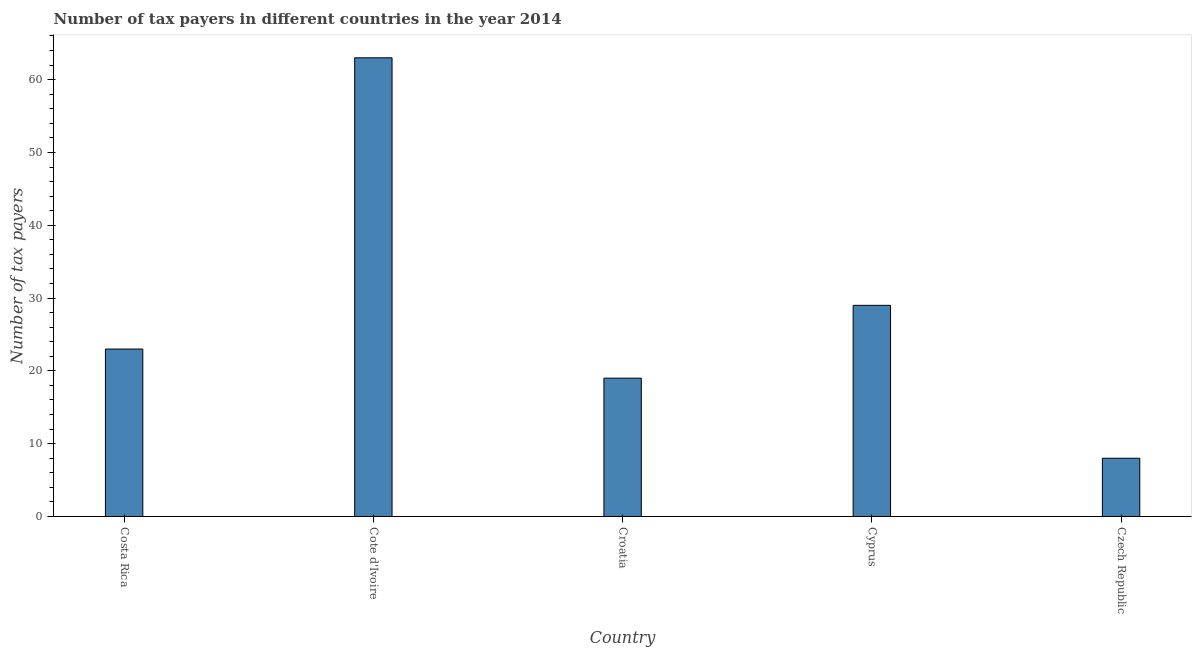Does the graph contain grids?
Your response must be concise. No. What is the title of the graph?
Ensure brevity in your answer.  Number of tax payers in different countries in the year 2014. What is the label or title of the Y-axis?
Your response must be concise. Number of tax payers. What is the number of tax payers in Croatia?
Give a very brief answer. 19. Across all countries, what is the maximum number of tax payers?
Ensure brevity in your answer.  63. Across all countries, what is the minimum number of tax payers?
Make the answer very short. 8. In which country was the number of tax payers maximum?
Make the answer very short. Cote d'Ivoire. In which country was the number of tax payers minimum?
Your answer should be very brief. Czech Republic. What is the sum of the number of tax payers?
Make the answer very short. 142. What is the difference between the number of tax payers in Costa Rica and Czech Republic?
Your answer should be compact. 15. What is the average number of tax payers per country?
Your response must be concise. 28.4. In how many countries, is the number of tax payers greater than 12 ?
Make the answer very short. 4. What is the ratio of the number of tax payers in Cyprus to that in Czech Republic?
Your response must be concise. 3.62. Is the number of tax payers in Croatia less than that in Cyprus?
Your answer should be very brief. Yes. What is the difference between the highest and the second highest number of tax payers?
Offer a very short reply. 34. What is the difference between the highest and the lowest number of tax payers?
Ensure brevity in your answer.  55. Are all the bars in the graph horizontal?
Your response must be concise. No. How many countries are there in the graph?
Provide a short and direct response. 5. Are the values on the major ticks of Y-axis written in scientific E-notation?
Offer a terse response. No. What is the Number of tax payers of Costa Rica?
Make the answer very short. 23. What is the Number of tax payers in Croatia?
Ensure brevity in your answer.  19. What is the Number of tax payers of Cyprus?
Your answer should be compact. 29. What is the Number of tax payers of Czech Republic?
Make the answer very short. 8. What is the difference between the Number of tax payers in Costa Rica and Cote d'Ivoire?
Make the answer very short. -40. What is the difference between the Number of tax payers in Costa Rica and Croatia?
Your response must be concise. 4. What is the difference between the Number of tax payers in Costa Rica and Cyprus?
Ensure brevity in your answer.  -6. What is the difference between the Number of tax payers in Costa Rica and Czech Republic?
Offer a terse response. 15. What is the difference between the Number of tax payers in Cote d'Ivoire and Croatia?
Provide a succinct answer. 44. What is the difference between the Number of tax payers in Croatia and Cyprus?
Offer a terse response. -10. What is the difference between the Number of tax payers in Croatia and Czech Republic?
Your answer should be very brief. 11. What is the ratio of the Number of tax payers in Costa Rica to that in Cote d'Ivoire?
Ensure brevity in your answer.  0.36. What is the ratio of the Number of tax payers in Costa Rica to that in Croatia?
Make the answer very short. 1.21. What is the ratio of the Number of tax payers in Costa Rica to that in Cyprus?
Keep it short and to the point. 0.79. What is the ratio of the Number of tax payers in Costa Rica to that in Czech Republic?
Give a very brief answer. 2.88. What is the ratio of the Number of tax payers in Cote d'Ivoire to that in Croatia?
Give a very brief answer. 3.32. What is the ratio of the Number of tax payers in Cote d'Ivoire to that in Cyprus?
Provide a short and direct response. 2.17. What is the ratio of the Number of tax payers in Cote d'Ivoire to that in Czech Republic?
Your response must be concise. 7.88. What is the ratio of the Number of tax payers in Croatia to that in Cyprus?
Your response must be concise. 0.66. What is the ratio of the Number of tax payers in Croatia to that in Czech Republic?
Offer a very short reply. 2.38. What is the ratio of the Number of tax payers in Cyprus to that in Czech Republic?
Make the answer very short. 3.62. 